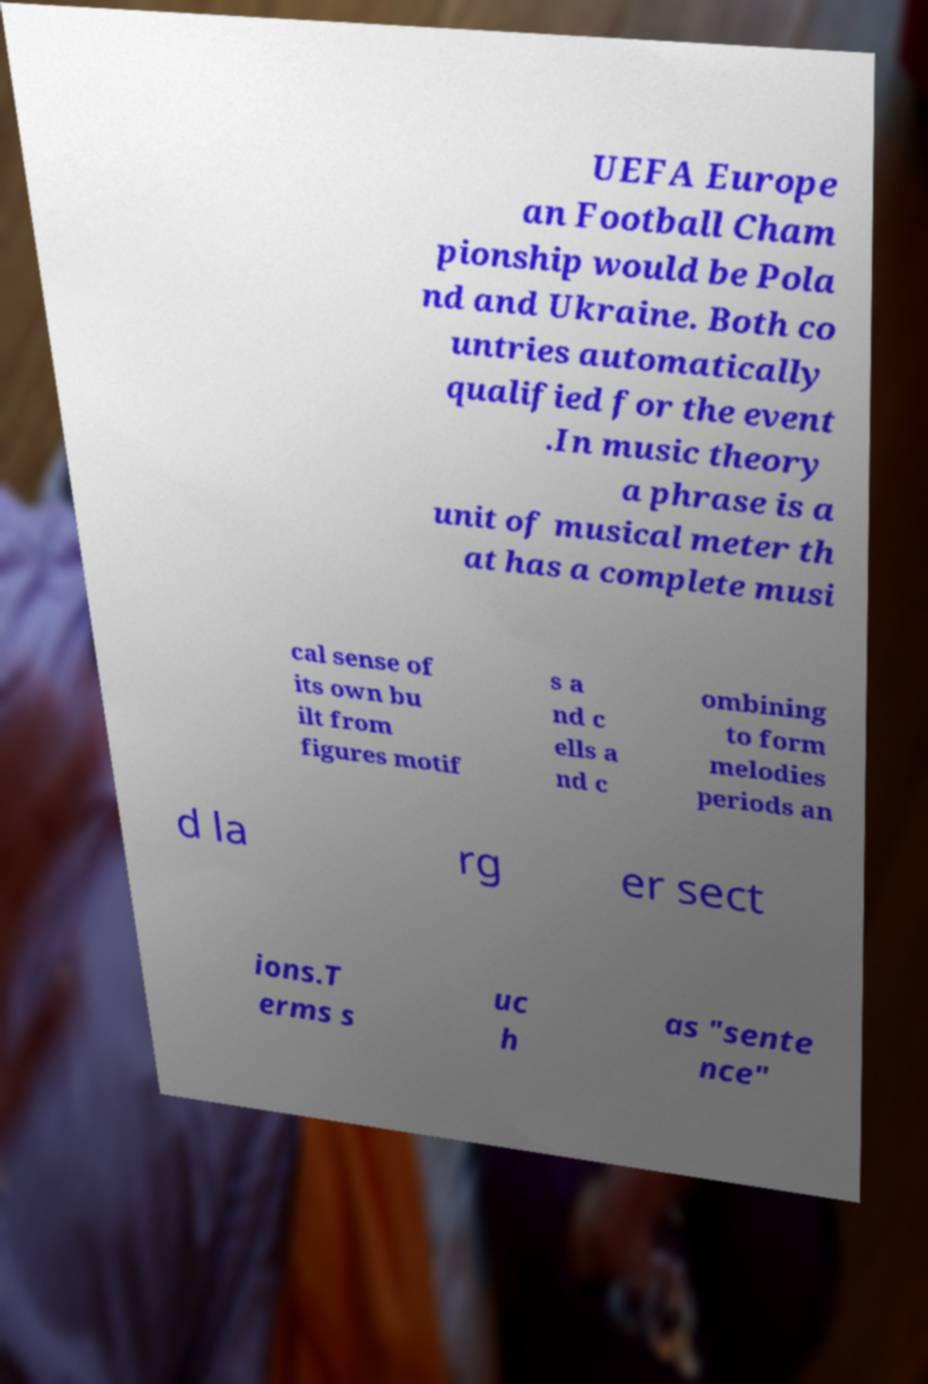Please read and relay the text visible in this image. What does it say? UEFA Europe an Football Cham pionship would be Pola nd and Ukraine. Both co untries automatically qualified for the event .In music theory a phrase is a unit of musical meter th at has a complete musi cal sense of its own bu ilt from figures motif s a nd c ells a nd c ombining to form melodies periods an d la rg er sect ions.T erms s uc h as "sente nce" 